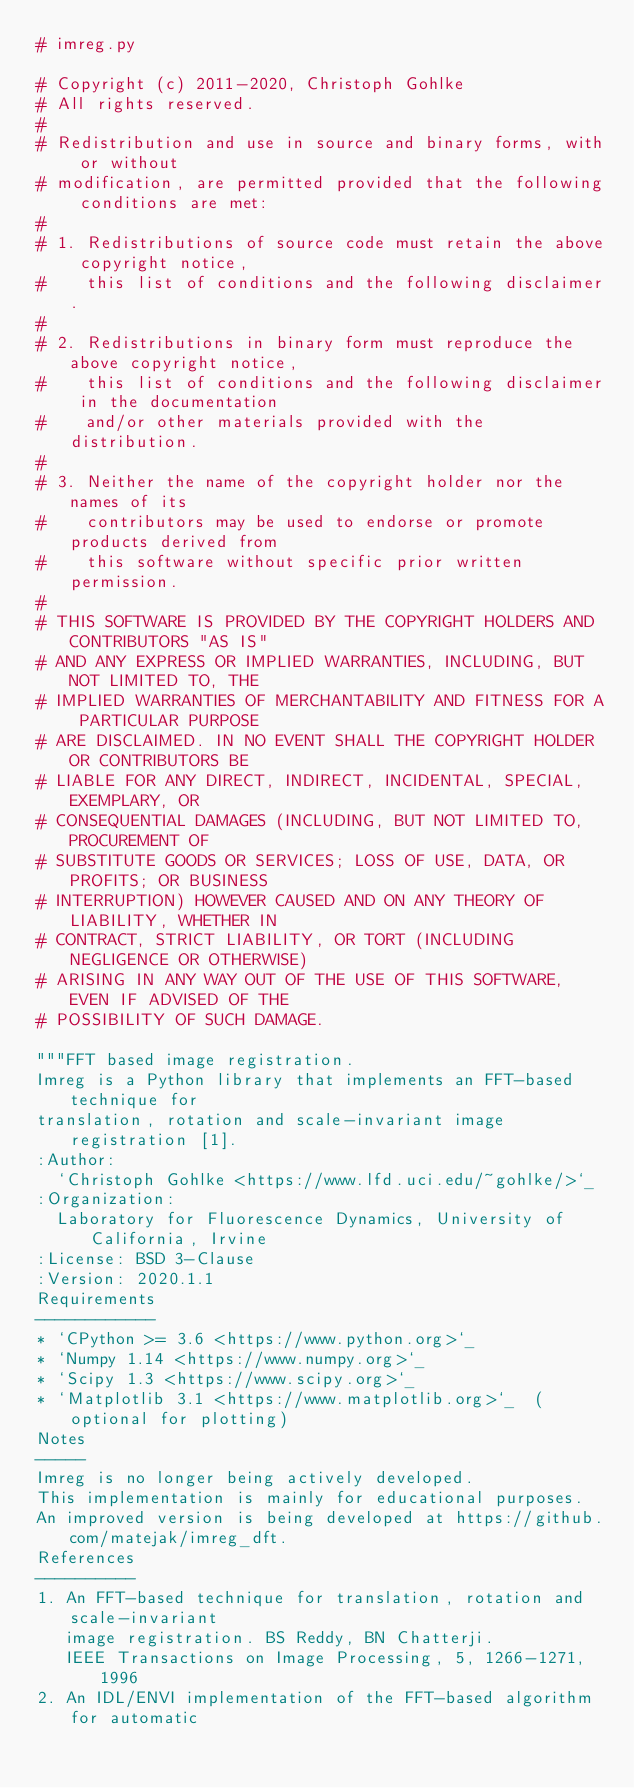Convert code to text. <code><loc_0><loc_0><loc_500><loc_500><_Python_># imreg.py

# Copyright (c) 2011-2020, Christoph Gohlke
# All rights reserved.
#
# Redistribution and use in source and binary forms, with or without
# modification, are permitted provided that the following conditions are met:
#
# 1. Redistributions of source code must retain the above copyright notice,
#    this list of conditions and the following disclaimer.
#
# 2. Redistributions in binary form must reproduce the above copyright notice,
#    this list of conditions and the following disclaimer in the documentation
#    and/or other materials provided with the distribution.
#
# 3. Neither the name of the copyright holder nor the names of its
#    contributors may be used to endorse or promote products derived from
#    this software without specific prior written permission.
#
# THIS SOFTWARE IS PROVIDED BY THE COPYRIGHT HOLDERS AND CONTRIBUTORS "AS IS"
# AND ANY EXPRESS OR IMPLIED WARRANTIES, INCLUDING, BUT NOT LIMITED TO, THE
# IMPLIED WARRANTIES OF MERCHANTABILITY AND FITNESS FOR A PARTICULAR PURPOSE
# ARE DISCLAIMED. IN NO EVENT SHALL THE COPYRIGHT HOLDER OR CONTRIBUTORS BE
# LIABLE FOR ANY DIRECT, INDIRECT, INCIDENTAL, SPECIAL, EXEMPLARY, OR
# CONSEQUENTIAL DAMAGES (INCLUDING, BUT NOT LIMITED TO, PROCUREMENT OF
# SUBSTITUTE GOODS OR SERVICES; LOSS OF USE, DATA, OR PROFITS; OR BUSINESS
# INTERRUPTION) HOWEVER CAUSED AND ON ANY THEORY OF LIABILITY, WHETHER IN
# CONTRACT, STRICT LIABILITY, OR TORT (INCLUDING NEGLIGENCE OR OTHERWISE)
# ARISING IN ANY WAY OUT OF THE USE OF THIS SOFTWARE, EVEN IF ADVISED OF THE
# POSSIBILITY OF SUCH DAMAGE.

"""FFT based image registration.
Imreg is a Python library that implements an FFT-based technique for
translation, rotation and scale-invariant image registration [1].
:Author:
  `Christoph Gohlke <https://www.lfd.uci.edu/~gohlke/>`_
:Organization:
  Laboratory for Fluorescence Dynamics, University of California, Irvine
:License: BSD 3-Clause
:Version: 2020.1.1
Requirements
------------
* `CPython >= 3.6 <https://www.python.org>`_
* `Numpy 1.14 <https://www.numpy.org>`_
* `Scipy 1.3 <https://www.scipy.org>`_
* `Matplotlib 3.1 <https://www.matplotlib.org>`_  (optional for plotting)
Notes
-----
Imreg is no longer being actively developed.
This implementation is mainly for educational purposes.
An improved version is being developed at https://github.com/matejak/imreg_dft.
References
----------
1. An FFT-based technique for translation, rotation and scale-invariant
   image registration. BS Reddy, BN Chatterji.
   IEEE Transactions on Image Processing, 5, 1266-1271, 1996
2. An IDL/ENVI implementation of the FFT-based algorithm for automatic</code> 